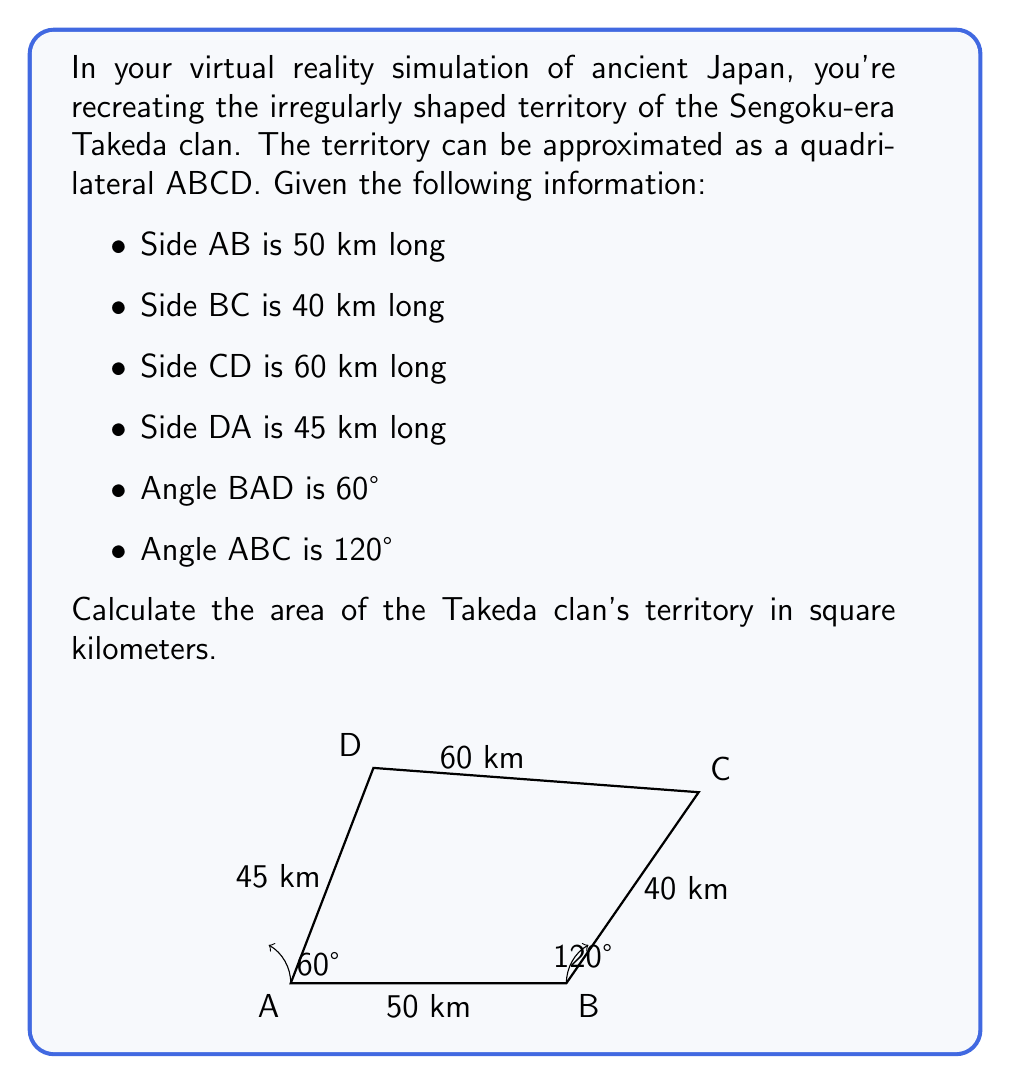Show me your answer to this math problem. To solve this problem, we'll use trigonometry to divide the quadrilateral into two triangles and calculate their areas separately.

Step 1: Divide the quadrilateral into triangles ABD and BCD.

Step 2: Calculate the area of triangle ABD using the formula:
$$\text{Area}_{\triangle ABD} = \frac{1}{2} \cdot AB \cdot AD \cdot \sin(\angle BAD)$$
$$\text{Area}_{\triangle ABD} = \frac{1}{2} \cdot 50 \cdot 45 \cdot \sin(60°) = \frac{1}{2} \cdot 50 \cdot 45 \cdot \frac{\sqrt{3}}{2} = 487.5\sqrt{3} \approx 844.33 \text{ km}^2$$

Step 3: Calculate angle BCD using the law of cosines:
$$BC^2 = AB^2 + CD^2 - 2 \cdot AB \cdot CD \cdot \cos(\angle BCD)$$
$$40^2 = 50^2 + 60^2 - 2 \cdot 50 \cdot 60 \cdot \cos(\angle BCD)$$
$$1600 = 2500 + 3600 - 6000 \cdot \cos(\angle BCD)$$
$$\cos(\angle BCD) = \frac{4500 - 1600}{6000} = \frac{2900}{6000} \approx 0.4833$$
$$\angle BCD = \arccos(0.4833) \approx 61.12°$$

Step 4: Calculate the area of triangle BCD:
$$\text{Area}_{\triangle BCD} = \frac{1}{2} \cdot BC \cdot CD \cdot \sin(\angle BCD)$$
$$\text{Area}_{\triangle BCD} = \frac{1}{2} \cdot 40 \cdot 60 \cdot \sin(61.12°) \approx 1050.67 \text{ km}^2$$

Step 5: Sum the areas of both triangles:
$$\text{Total Area} = \text{Area}_{\triangle ABD} + \text{Area}_{\triangle BCD}$$
$$\text{Total Area} \approx 844.33 + 1050.67 = 1895 \text{ km}^2$$
Answer: 1895 km² 